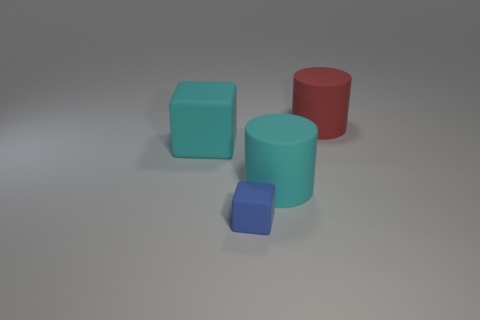Is the number of rubber cylinders to the left of the tiny blue object the same as the number of cyan shiny cylinders?
Your response must be concise. Yes. How many other objects are the same material as the blue object?
Offer a terse response. 3. There is a matte cylinder in front of the red object; is its size the same as the block on the left side of the tiny blue block?
Make the answer very short. Yes. How many things are either cyan rubber things to the left of the blue cube or rubber things that are right of the big matte block?
Ensure brevity in your answer.  4. There is a large rubber object to the left of the cyan cylinder; does it have the same color as the rubber cylinder that is in front of the large cyan cube?
Make the answer very short. Yes. What number of matte things are red cylinders or small blue objects?
Offer a terse response. 2. Is there anything else that has the same size as the blue cube?
Offer a very short reply. No. What shape is the large cyan rubber object that is behind the big cyan thing that is on the right side of the blue matte cube?
Offer a very short reply. Cube. How many cyan matte cylinders are right of the big cyan rubber object that is to the right of the blue rubber block?
Provide a short and direct response. 0. There is a cyan object that is to the left of the blue matte object; is its shape the same as the blue thing that is in front of the large matte cube?
Provide a short and direct response. Yes. 